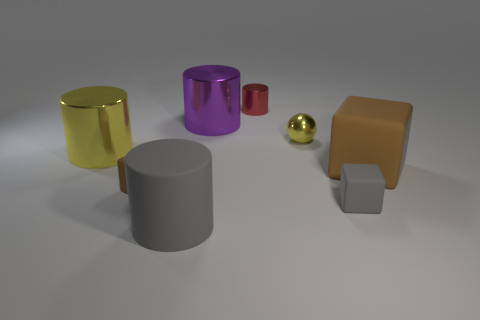What number of other objects are the same shape as the big yellow metal thing?
Provide a short and direct response. 3. Is the shape of the small brown rubber thing the same as the large thing in front of the tiny brown matte object?
Provide a short and direct response. No. How many red shiny cylinders are behind the gray rubber cylinder?
Offer a terse response. 1. Is there a thing that has the same size as the matte cylinder?
Offer a very short reply. Yes. Is the shape of the purple object in front of the red cylinder the same as  the red metal object?
Offer a terse response. Yes. What is the color of the small cylinder?
Make the answer very short. Red. What is the shape of the object that is the same color as the rubber cylinder?
Offer a very short reply. Cube. Are there any yellow shiny spheres?
Make the answer very short. Yes. The gray cylinder that is made of the same material as the small brown thing is what size?
Keep it short and to the point. Large. What shape is the big object that is behind the yellow object that is behind the shiny cylinder to the left of the big gray matte object?
Your answer should be compact. Cylinder. 